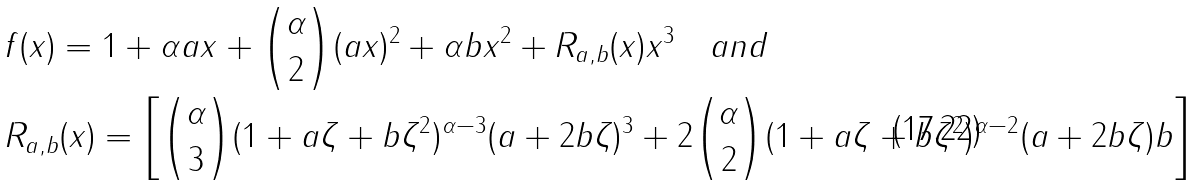<formula> <loc_0><loc_0><loc_500><loc_500>& f ( x ) = 1 + \alpha a x + \binom { \alpha } { 2 } ( a x ) ^ { 2 } + \alpha b x ^ { 2 } + R _ { a , b } ( x ) x ^ { 3 } \quad a n d \\ & R _ { a , b } ( x ) = \left [ \binom { \alpha } { 3 } ( 1 + a \zeta + b \zeta ^ { 2 } ) ^ { \alpha - 3 } ( a + 2 b \zeta ) ^ { 3 } + 2 \binom { \alpha } { 2 } ( 1 + a \zeta + b \zeta ^ { 2 } ) ^ { \alpha - 2 } ( a + 2 b \zeta ) b \right ]</formula> 